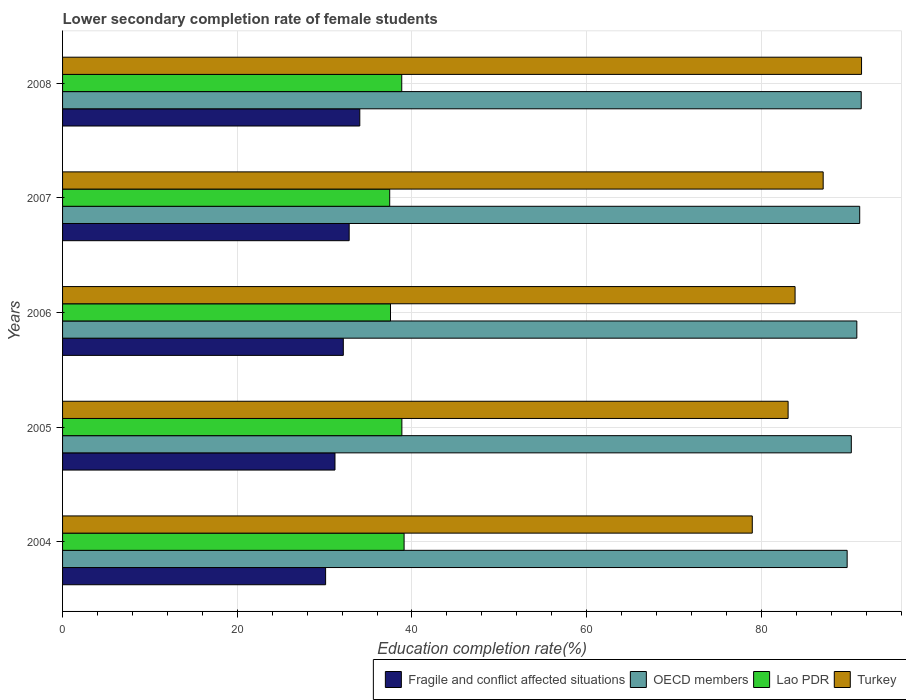How many groups of bars are there?
Give a very brief answer. 5. Are the number of bars per tick equal to the number of legend labels?
Your response must be concise. Yes. Are the number of bars on each tick of the Y-axis equal?
Provide a short and direct response. Yes. What is the label of the 4th group of bars from the top?
Provide a succinct answer. 2005. What is the lower secondary completion rate of female students in OECD members in 2004?
Your response must be concise. 89.82. Across all years, what is the maximum lower secondary completion rate of female students in Lao PDR?
Make the answer very short. 39.1. Across all years, what is the minimum lower secondary completion rate of female students in OECD members?
Offer a very short reply. 89.82. What is the total lower secondary completion rate of female students in Lao PDR in the graph?
Give a very brief answer. 191.76. What is the difference between the lower secondary completion rate of female students in Lao PDR in 2004 and that in 2005?
Your answer should be compact. 0.25. What is the difference between the lower secondary completion rate of female students in OECD members in 2006 and the lower secondary completion rate of female students in Fragile and conflict affected situations in 2005?
Provide a succinct answer. 59.74. What is the average lower secondary completion rate of female students in Lao PDR per year?
Give a very brief answer. 38.35. In the year 2006, what is the difference between the lower secondary completion rate of female students in Turkey and lower secondary completion rate of female students in Lao PDR?
Give a very brief answer. 46.31. In how many years, is the lower secondary completion rate of female students in OECD members greater than 4 %?
Your answer should be very brief. 5. What is the ratio of the lower secondary completion rate of female students in OECD members in 2004 to that in 2007?
Your response must be concise. 0.98. Is the lower secondary completion rate of female students in Lao PDR in 2004 less than that in 2006?
Your answer should be compact. No. What is the difference between the highest and the second highest lower secondary completion rate of female students in OECD members?
Offer a terse response. 0.17. What is the difference between the highest and the lowest lower secondary completion rate of female students in Fragile and conflict affected situations?
Provide a succinct answer. 3.91. What does the 4th bar from the top in 2008 represents?
Provide a short and direct response. Fragile and conflict affected situations. What does the 1st bar from the bottom in 2005 represents?
Your answer should be compact. Fragile and conflict affected situations. How many years are there in the graph?
Your response must be concise. 5. What is the difference between two consecutive major ticks on the X-axis?
Provide a succinct answer. 20. Does the graph contain grids?
Offer a terse response. Yes. Where does the legend appear in the graph?
Give a very brief answer. Bottom right. How many legend labels are there?
Make the answer very short. 4. How are the legend labels stacked?
Give a very brief answer. Horizontal. What is the title of the graph?
Give a very brief answer. Lower secondary completion rate of female students. Does "Australia" appear as one of the legend labels in the graph?
Provide a succinct answer. No. What is the label or title of the X-axis?
Your response must be concise. Education completion rate(%). What is the Education completion rate(%) of Fragile and conflict affected situations in 2004?
Offer a terse response. 30.11. What is the Education completion rate(%) in OECD members in 2004?
Your answer should be compact. 89.82. What is the Education completion rate(%) of Lao PDR in 2004?
Your answer should be compact. 39.1. What is the Education completion rate(%) in Turkey in 2004?
Your answer should be compact. 78.96. What is the Education completion rate(%) of Fragile and conflict affected situations in 2005?
Keep it short and to the point. 31.19. What is the Education completion rate(%) of OECD members in 2005?
Your answer should be compact. 90.29. What is the Education completion rate(%) of Lao PDR in 2005?
Provide a succinct answer. 38.84. What is the Education completion rate(%) in Turkey in 2005?
Provide a short and direct response. 83.06. What is the Education completion rate(%) in Fragile and conflict affected situations in 2006?
Offer a very short reply. 32.14. What is the Education completion rate(%) in OECD members in 2006?
Keep it short and to the point. 90.93. What is the Education completion rate(%) of Lao PDR in 2006?
Provide a succinct answer. 37.54. What is the Education completion rate(%) in Turkey in 2006?
Provide a succinct answer. 83.86. What is the Education completion rate(%) of Fragile and conflict affected situations in 2007?
Give a very brief answer. 32.81. What is the Education completion rate(%) in OECD members in 2007?
Give a very brief answer. 91.25. What is the Education completion rate(%) in Lao PDR in 2007?
Your response must be concise. 37.45. What is the Education completion rate(%) of Turkey in 2007?
Provide a succinct answer. 87.07. What is the Education completion rate(%) of Fragile and conflict affected situations in 2008?
Give a very brief answer. 34.03. What is the Education completion rate(%) in OECD members in 2008?
Keep it short and to the point. 91.43. What is the Education completion rate(%) of Lao PDR in 2008?
Give a very brief answer. 38.83. What is the Education completion rate(%) in Turkey in 2008?
Ensure brevity in your answer.  91.46. Across all years, what is the maximum Education completion rate(%) of Fragile and conflict affected situations?
Provide a short and direct response. 34.03. Across all years, what is the maximum Education completion rate(%) in OECD members?
Provide a short and direct response. 91.43. Across all years, what is the maximum Education completion rate(%) in Lao PDR?
Keep it short and to the point. 39.1. Across all years, what is the maximum Education completion rate(%) of Turkey?
Provide a short and direct response. 91.46. Across all years, what is the minimum Education completion rate(%) in Fragile and conflict affected situations?
Your answer should be very brief. 30.11. Across all years, what is the minimum Education completion rate(%) of OECD members?
Give a very brief answer. 89.82. Across all years, what is the minimum Education completion rate(%) in Lao PDR?
Provide a short and direct response. 37.45. Across all years, what is the minimum Education completion rate(%) of Turkey?
Your response must be concise. 78.96. What is the total Education completion rate(%) of Fragile and conflict affected situations in the graph?
Ensure brevity in your answer.  160.27. What is the total Education completion rate(%) in OECD members in the graph?
Offer a terse response. 453.72. What is the total Education completion rate(%) in Lao PDR in the graph?
Offer a terse response. 191.76. What is the total Education completion rate(%) of Turkey in the graph?
Your response must be concise. 424.41. What is the difference between the Education completion rate(%) of Fragile and conflict affected situations in 2004 and that in 2005?
Ensure brevity in your answer.  -1.07. What is the difference between the Education completion rate(%) in OECD members in 2004 and that in 2005?
Give a very brief answer. -0.48. What is the difference between the Education completion rate(%) in Lao PDR in 2004 and that in 2005?
Your response must be concise. 0.25. What is the difference between the Education completion rate(%) in Turkey in 2004 and that in 2005?
Provide a succinct answer. -4.1. What is the difference between the Education completion rate(%) in Fragile and conflict affected situations in 2004 and that in 2006?
Give a very brief answer. -2.03. What is the difference between the Education completion rate(%) of OECD members in 2004 and that in 2006?
Keep it short and to the point. -1.11. What is the difference between the Education completion rate(%) of Lao PDR in 2004 and that in 2006?
Offer a very short reply. 1.56. What is the difference between the Education completion rate(%) in Turkey in 2004 and that in 2006?
Make the answer very short. -4.9. What is the difference between the Education completion rate(%) of Fragile and conflict affected situations in 2004 and that in 2007?
Your answer should be very brief. -2.7. What is the difference between the Education completion rate(%) of OECD members in 2004 and that in 2007?
Your answer should be compact. -1.44. What is the difference between the Education completion rate(%) of Lao PDR in 2004 and that in 2007?
Make the answer very short. 1.65. What is the difference between the Education completion rate(%) in Turkey in 2004 and that in 2007?
Offer a terse response. -8.12. What is the difference between the Education completion rate(%) in Fragile and conflict affected situations in 2004 and that in 2008?
Make the answer very short. -3.91. What is the difference between the Education completion rate(%) of OECD members in 2004 and that in 2008?
Ensure brevity in your answer.  -1.61. What is the difference between the Education completion rate(%) of Lao PDR in 2004 and that in 2008?
Provide a short and direct response. 0.27. What is the difference between the Education completion rate(%) in Turkey in 2004 and that in 2008?
Keep it short and to the point. -12.51. What is the difference between the Education completion rate(%) in Fragile and conflict affected situations in 2005 and that in 2006?
Make the answer very short. -0.95. What is the difference between the Education completion rate(%) in OECD members in 2005 and that in 2006?
Make the answer very short. -0.63. What is the difference between the Education completion rate(%) in Lao PDR in 2005 and that in 2006?
Your answer should be compact. 1.3. What is the difference between the Education completion rate(%) of Turkey in 2005 and that in 2006?
Your answer should be compact. -0.8. What is the difference between the Education completion rate(%) in Fragile and conflict affected situations in 2005 and that in 2007?
Make the answer very short. -1.62. What is the difference between the Education completion rate(%) in OECD members in 2005 and that in 2007?
Give a very brief answer. -0.96. What is the difference between the Education completion rate(%) in Lao PDR in 2005 and that in 2007?
Ensure brevity in your answer.  1.39. What is the difference between the Education completion rate(%) of Turkey in 2005 and that in 2007?
Your response must be concise. -4.01. What is the difference between the Education completion rate(%) in Fragile and conflict affected situations in 2005 and that in 2008?
Make the answer very short. -2.84. What is the difference between the Education completion rate(%) of OECD members in 2005 and that in 2008?
Make the answer very short. -1.13. What is the difference between the Education completion rate(%) in Lao PDR in 2005 and that in 2008?
Keep it short and to the point. 0.02. What is the difference between the Education completion rate(%) of Turkey in 2005 and that in 2008?
Your answer should be compact. -8.41. What is the difference between the Education completion rate(%) in Fragile and conflict affected situations in 2006 and that in 2007?
Offer a very short reply. -0.67. What is the difference between the Education completion rate(%) in OECD members in 2006 and that in 2007?
Your response must be concise. -0.33. What is the difference between the Education completion rate(%) in Lao PDR in 2006 and that in 2007?
Provide a short and direct response. 0.09. What is the difference between the Education completion rate(%) in Turkey in 2006 and that in 2007?
Offer a very short reply. -3.22. What is the difference between the Education completion rate(%) of Fragile and conflict affected situations in 2006 and that in 2008?
Give a very brief answer. -1.89. What is the difference between the Education completion rate(%) in OECD members in 2006 and that in 2008?
Provide a short and direct response. -0.5. What is the difference between the Education completion rate(%) of Lao PDR in 2006 and that in 2008?
Offer a terse response. -1.29. What is the difference between the Education completion rate(%) in Turkey in 2006 and that in 2008?
Your response must be concise. -7.61. What is the difference between the Education completion rate(%) of Fragile and conflict affected situations in 2007 and that in 2008?
Offer a terse response. -1.22. What is the difference between the Education completion rate(%) in OECD members in 2007 and that in 2008?
Your answer should be compact. -0.17. What is the difference between the Education completion rate(%) of Lao PDR in 2007 and that in 2008?
Offer a terse response. -1.38. What is the difference between the Education completion rate(%) in Turkey in 2007 and that in 2008?
Provide a succinct answer. -4.39. What is the difference between the Education completion rate(%) of Fragile and conflict affected situations in 2004 and the Education completion rate(%) of OECD members in 2005?
Provide a short and direct response. -60.18. What is the difference between the Education completion rate(%) of Fragile and conflict affected situations in 2004 and the Education completion rate(%) of Lao PDR in 2005?
Ensure brevity in your answer.  -8.73. What is the difference between the Education completion rate(%) of Fragile and conflict affected situations in 2004 and the Education completion rate(%) of Turkey in 2005?
Offer a very short reply. -52.95. What is the difference between the Education completion rate(%) in OECD members in 2004 and the Education completion rate(%) in Lao PDR in 2005?
Make the answer very short. 50.97. What is the difference between the Education completion rate(%) in OECD members in 2004 and the Education completion rate(%) in Turkey in 2005?
Your response must be concise. 6.76. What is the difference between the Education completion rate(%) of Lao PDR in 2004 and the Education completion rate(%) of Turkey in 2005?
Keep it short and to the point. -43.96. What is the difference between the Education completion rate(%) of Fragile and conflict affected situations in 2004 and the Education completion rate(%) of OECD members in 2006?
Provide a short and direct response. -60.81. What is the difference between the Education completion rate(%) in Fragile and conflict affected situations in 2004 and the Education completion rate(%) in Lao PDR in 2006?
Ensure brevity in your answer.  -7.43. What is the difference between the Education completion rate(%) in Fragile and conflict affected situations in 2004 and the Education completion rate(%) in Turkey in 2006?
Offer a terse response. -53.74. What is the difference between the Education completion rate(%) in OECD members in 2004 and the Education completion rate(%) in Lao PDR in 2006?
Provide a short and direct response. 52.28. What is the difference between the Education completion rate(%) in OECD members in 2004 and the Education completion rate(%) in Turkey in 2006?
Your answer should be compact. 5.96. What is the difference between the Education completion rate(%) of Lao PDR in 2004 and the Education completion rate(%) of Turkey in 2006?
Keep it short and to the point. -44.76. What is the difference between the Education completion rate(%) of Fragile and conflict affected situations in 2004 and the Education completion rate(%) of OECD members in 2007?
Give a very brief answer. -61.14. What is the difference between the Education completion rate(%) of Fragile and conflict affected situations in 2004 and the Education completion rate(%) of Lao PDR in 2007?
Give a very brief answer. -7.34. What is the difference between the Education completion rate(%) of Fragile and conflict affected situations in 2004 and the Education completion rate(%) of Turkey in 2007?
Ensure brevity in your answer.  -56.96. What is the difference between the Education completion rate(%) in OECD members in 2004 and the Education completion rate(%) in Lao PDR in 2007?
Offer a very short reply. 52.37. What is the difference between the Education completion rate(%) in OECD members in 2004 and the Education completion rate(%) in Turkey in 2007?
Keep it short and to the point. 2.75. What is the difference between the Education completion rate(%) in Lao PDR in 2004 and the Education completion rate(%) in Turkey in 2007?
Make the answer very short. -47.98. What is the difference between the Education completion rate(%) in Fragile and conflict affected situations in 2004 and the Education completion rate(%) in OECD members in 2008?
Your answer should be compact. -61.31. What is the difference between the Education completion rate(%) of Fragile and conflict affected situations in 2004 and the Education completion rate(%) of Lao PDR in 2008?
Your response must be concise. -8.71. What is the difference between the Education completion rate(%) of Fragile and conflict affected situations in 2004 and the Education completion rate(%) of Turkey in 2008?
Your answer should be compact. -61.35. What is the difference between the Education completion rate(%) of OECD members in 2004 and the Education completion rate(%) of Lao PDR in 2008?
Give a very brief answer. 50.99. What is the difference between the Education completion rate(%) of OECD members in 2004 and the Education completion rate(%) of Turkey in 2008?
Keep it short and to the point. -1.65. What is the difference between the Education completion rate(%) of Lao PDR in 2004 and the Education completion rate(%) of Turkey in 2008?
Offer a very short reply. -52.37. What is the difference between the Education completion rate(%) of Fragile and conflict affected situations in 2005 and the Education completion rate(%) of OECD members in 2006?
Provide a short and direct response. -59.74. What is the difference between the Education completion rate(%) in Fragile and conflict affected situations in 2005 and the Education completion rate(%) in Lao PDR in 2006?
Keep it short and to the point. -6.36. What is the difference between the Education completion rate(%) in Fragile and conflict affected situations in 2005 and the Education completion rate(%) in Turkey in 2006?
Offer a terse response. -52.67. What is the difference between the Education completion rate(%) in OECD members in 2005 and the Education completion rate(%) in Lao PDR in 2006?
Give a very brief answer. 52.75. What is the difference between the Education completion rate(%) in OECD members in 2005 and the Education completion rate(%) in Turkey in 2006?
Offer a very short reply. 6.44. What is the difference between the Education completion rate(%) in Lao PDR in 2005 and the Education completion rate(%) in Turkey in 2006?
Provide a succinct answer. -45.01. What is the difference between the Education completion rate(%) in Fragile and conflict affected situations in 2005 and the Education completion rate(%) in OECD members in 2007?
Your answer should be very brief. -60.07. What is the difference between the Education completion rate(%) of Fragile and conflict affected situations in 2005 and the Education completion rate(%) of Lao PDR in 2007?
Your answer should be compact. -6.26. What is the difference between the Education completion rate(%) of Fragile and conflict affected situations in 2005 and the Education completion rate(%) of Turkey in 2007?
Give a very brief answer. -55.89. What is the difference between the Education completion rate(%) of OECD members in 2005 and the Education completion rate(%) of Lao PDR in 2007?
Offer a terse response. 52.84. What is the difference between the Education completion rate(%) in OECD members in 2005 and the Education completion rate(%) in Turkey in 2007?
Keep it short and to the point. 3.22. What is the difference between the Education completion rate(%) of Lao PDR in 2005 and the Education completion rate(%) of Turkey in 2007?
Your answer should be compact. -48.23. What is the difference between the Education completion rate(%) of Fragile and conflict affected situations in 2005 and the Education completion rate(%) of OECD members in 2008?
Your response must be concise. -60.24. What is the difference between the Education completion rate(%) of Fragile and conflict affected situations in 2005 and the Education completion rate(%) of Lao PDR in 2008?
Your answer should be very brief. -7.64. What is the difference between the Education completion rate(%) of Fragile and conflict affected situations in 2005 and the Education completion rate(%) of Turkey in 2008?
Make the answer very short. -60.28. What is the difference between the Education completion rate(%) in OECD members in 2005 and the Education completion rate(%) in Lao PDR in 2008?
Keep it short and to the point. 51.47. What is the difference between the Education completion rate(%) of OECD members in 2005 and the Education completion rate(%) of Turkey in 2008?
Offer a very short reply. -1.17. What is the difference between the Education completion rate(%) in Lao PDR in 2005 and the Education completion rate(%) in Turkey in 2008?
Your response must be concise. -52.62. What is the difference between the Education completion rate(%) in Fragile and conflict affected situations in 2006 and the Education completion rate(%) in OECD members in 2007?
Your response must be concise. -59.12. What is the difference between the Education completion rate(%) in Fragile and conflict affected situations in 2006 and the Education completion rate(%) in Lao PDR in 2007?
Provide a short and direct response. -5.31. What is the difference between the Education completion rate(%) in Fragile and conflict affected situations in 2006 and the Education completion rate(%) in Turkey in 2007?
Offer a terse response. -54.93. What is the difference between the Education completion rate(%) of OECD members in 2006 and the Education completion rate(%) of Lao PDR in 2007?
Your answer should be very brief. 53.48. What is the difference between the Education completion rate(%) in OECD members in 2006 and the Education completion rate(%) in Turkey in 2007?
Your answer should be compact. 3.85. What is the difference between the Education completion rate(%) in Lao PDR in 2006 and the Education completion rate(%) in Turkey in 2007?
Offer a very short reply. -49.53. What is the difference between the Education completion rate(%) in Fragile and conflict affected situations in 2006 and the Education completion rate(%) in OECD members in 2008?
Your answer should be compact. -59.29. What is the difference between the Education completion rate(%) of Fragile and conflict affected situations in 2006 and the Education completion rate(%) of Lao PDR in 2008?
Your answer should be very brief. -6.69. What is the difference between the Education completion rate(%) of Fragile and conflict affected situations in 2006 and the Education completion rate(%) of Turkey in 2008?
Offer a very short reply. -59.33. What is the difference between the Education completion rate(%) in OECD members in 2006 and the Education completion rate(%) in Lao PDR in 2008?
Your answer should be compact. 52.1. What is the difference between the Education completion rate(%) in OECD members in 2006 and the Education completion rate(%) in Turkey in 2008?
Ensure brevity in your answer.  -0.54. What is the difference between the Education completion rate(%) of Lao PDR in 2006 and the Education completion rate(%) of Turkey in 2008?
Your response must be concise. -53.92. What is the difference between the Education completion rate(%) of Fragile and conflict affected situations in 2007 and the Education completion rate(%) of OECD members in 2008?
Keep it short and to the point. -58.62. What is the difference between the Education completion rate(%) in Fragile and conflict affected situations in 2007 and the Education completion rate(%) in Lao PDR in 2008?
Ensure brevity in your answer.  -6.02. What is the difference between the Education completion rate(%) of Fragile and conflict affected situations in 2007 and the Education completion rate(%) of Turkey in 2008?
Your response must be concise. -58.65. What is the difference between the Education completion rate(%) of OECD members in 2007 and the Education completion rate(%) of Lao PDR in 2008?
Ensure brevity in your answer.  52.43. What is the difference between the Education completion rate(%) of OECD members in 2007 and the Education completion rate(%) of Turkey in 2008?
Your answer should be compact. -0.21. What is the difference between the Education completion rate(%) of Lao PDR in 2007 and the Education completion rate(%) of Turkey in 2008?
Your answer should be compact. -54.01. What is the average Education completion rate(%) of Fragile and conflict affected situations per year?
Keep it short and to the point. 32.05. What is the average Education completion rate(%) in OECD members per year?
Make the answer very short. 90.74. What is the average Education completion rate(%) in Lao PDR per year?
Provide a succinct answer. 38.35. What is the average Education completion rate(%) in Turkey per year?
Provide a succinct answer. 84.88. In the year 2004, what is the difference between the Education completion rate(%) of Fragile and conflict affected situations and Education completion rate(%) of OECD members?
Provide a short and direct response. -59.7. In the year 2004, what is the difference between the Education completion rate(%) in Fragile and conflict affected situations and Education completion rate(%) in Lao PDR?
Your response must be concise. -8.98. In the year 2004, what is the difference between the Education completion rate(%) of Fragile and conflict affected situations and Education completion rate(%) of Turkey?
Your response must be concise. -48.84. In the year 2004, what is the difference between the Education completion rate(%) in OECD members and Education completion rate(%) in Lao PDR?
Your response must be concise. 50.72. In the year 2004, what is the difference between the Education completion rate(%) in OECD members and Education completion rate(%) in Turkey?
Provide a short and direct response. 10.86. In the year 2004, what is the difference between the Education completion rate(%) of Lao PDR and Education completion rate(%) of Turkey?
Your answer should be compact. -39.86. In the year 2005, what is the difference between the Education completion rate(%) of Fragile and conflict affected situations and Education completion rate(%) of OECD members?
Keep it short and to the point. -59.11. In the year 2005, what is the difference between the Education completion rate(%) of Fragile and conflict affected situations and Education completion rate(%) of Lao PDR?
Your answer should be very brief. -7.66. In the year 2005, what is the difference between the Education completion rate(%) in Fragile and conflict affected situations and Education completion rate(%) in Turkey?
Your answer should be compact. -51.87. In the year 2005, what is the difference between the Education completion rate(%) of OECD members and Education completion rate(%) of Lao PDR?
Provide a succinct answer. 51.45. In the year 2005, what is the difference between the Education completion rate(%) in OECD members and Education completion rate(%) in Turkey?
Your answer should be compact. 7.24. In the year 2005, what is the difference between the Education completion rate(%) in Lao PDR and Education completion rate(%) in Turkey?
Give a very brief answer. -44.21. In the year 2006, what is the difference between the Education completion rate(%) in Fragile and conflict affected situations and Education completion rate(%) in OECD members?
Your answer should be compact. -58.79. In the year 2006, what is the difference between the Education completion rate(%) of Fragile and conflict affected situations and Education completion rate(%) of Lao PDR?
Make the answer very short. -5.4. In the year 2006, what is the difference between the Education completion rate(%) of Fragile and conflict affected situations and Education completion rate(%) of Turkey?
Your answer should be very brief. -51.72. In the year 2006, what is the difference between the Education completion rate(%) of OECD members and Education completion rate(%) of Lao PDR?
Your answer should be compact. 53.38. In the year 2006, what is the difference between the Education completion rate(%) of OECD members and Education completion rate(%) of Turkey?
Give a very brief answer. 7.07. In the year 2006, what is the difference between the Education completion rate(%) in Lao PDR and Education completion rate(%) in Turkey?
Provide a short and direct response. -46.31. In the year 2007, what is the difference between the Education completion rate(%) in Fragile and conflict affected situations and Education completion rate(%) in OECD members?
Make the answer very short. -58.44. In the year 2007, what is the difference between the Education completion rate(%) in Fragile and conflict affected situations and Education completion rate(%) in Lao PDR?
Ensure brevity in your answer.  -4.64. In the year 2007, what is the difference between the Education completion rate(%) of Fragile and conflict affected situations and Education completion rate(%) of Turkey?
Provide a succinct answer. -54.26. In the year 2007, what is the difference between the Education completion rate(%) of OECD members and Education completion rate(%) of Lao PDR?
Ensure brevity in your answer.  53.8. In the year 2007, what is the difference between the Education completion rate(%) of OECD members and Education completion rate(%) of Turkey?
Your response must be concise. 4.18. In the year 2007, what is the difference between the Education completion rate(%) in Lao PDR and Education completion rate(%) in Turkey?
Offer a terse response. -49.62. In the year 2008, what is the difference between the Education completion rate(%) of Fragile and conflict affected situations and Education completion rate(%) of OECD members?
Ensure brevity in your answer.  -57.4. In the year 2008, what is the difference between the Education completion rate(%) in Fragile and conflict affected situations and Education completion rate(%) in Lao PDR?
Make the answer very short. -4.8. In the year 2008, what is the difference between the Education completion rate(%) of Fragile and conflict affected situations and Education completion rate(%) of Turkey?
Offer a terse response. -57.44. In the year 2008, what is the difference between the Education completion rate(%) in OECD members and Education completion rate(%) in Lao PDR?
Your response must be concise. 52.6. In the year 2008, what is the difference between the Education completion rate(%) of OECD members and Education completion rate(%) of Turkey?
Keep it short and to the point. -0.04. In the year 2008, what is the difference between the Education completion rate(%) of Lao PDR and Education completion rate(%) of Turkey?
Make the answer very short. -52.64. What is the ratio of the Education completion rate(%) in Fragile and conflict affected situations in 2004 to that in 2005?
Your response must be concise. 0.97. What is the ratio of the Education completion rate(%) in OECD members in 2004 to that in 2005?
Give a very brief answer. 0.99. What is the ratio of the Education completion rate(%) of Lao PDR in 2004 to that in 2005?
Ensure brevity in your answer.  1.01. What is the ratio of the Education completion rate(%) in Turkey in 2004 to that in 2005?
Offer a very short reply. 0.95. What is the ratio of the Education completion rate(%) of Fragile and conflict affected situations in 2004 to that in 2006?
Keep it short and to the point. 0.94. What is the ratio of the Education completion rate(%) of Lao PDR in 2004 to that in 2006?
Ensure brevity in your answer.  1.04. What is the ratio of the Education completion rate(%) in Turkey in 2004 to that in 2006?
Keep it short and to the point. 0.94. What is the ratio of the Education completion rate(%) of Fragile and conflict affected situations in 2004 to that in 2007?
Give a very brief answer. 0.92. What is the ratio of the Education completion rate(%) in OECD members in 2004 to that in 2007?
Your answer should be very brief. 0.98. What is the ratio of the Education completion rate(%) of Lao PDR in 2004 to that in 2007?
Keep it short and to the point. 1.04. What is the ratio of the Education completion rate(%) in Turkey in 2004 to that in 2007?
Provide a short and direct response. 0.91. What is the ratio of the Education completion rate(%) of Fragile and conflict affected situations in 2004 to that in 2008?
Your answer should be very brief. 0.89. What is the ratio of the Education completion rate(%) of OECD members in 2004 to that in 2008?
Offer a very short reply. 0.98. What is the ratio of the Education completion rate(%) of Lao PDR in 2004 to that in 2008?
Keep it short and to the point. 1.01. What is the ratio of the Education completion rate(%) of Turkey in 2004 to that in 2008?
Keep it short and to the point. 0.86. What is the ratio of the Education completion rate(%) in Fragile and conflict affected situations in 2005 to that in 2006?
Give a very brief answer. 0.97. What is the ratio of the Education completion rate(%) of Lao PDR in 2005 to that in 2006?
Ensure brevity in your answer.  1.03. What is the ratio of the Education completion rate(%) in Turkey in 2005 to that in 2006?
Ensure brevity in your answer.  0.99. What is the ratio of the Education completion rate(%) of Fragile and conflict affected situations in 2005 to that in 2007?
Provide a succinct answer. 0.95. What is the ratio of the Education completion rate(%) in Lao PDR in 2005 to that in 2007?
Ensure brevity in your answer.  1.04. What is the ratio of the Education completion rate(%) of Turkey in 2005 to that in 2007?
Your answer should be very brief. 0.95. What is the ratio of the Education completion rate(%) in Fragile and conflict affected situations in 2005 to that in 2008?
Your answer should be very brief. 0.92. What is the ratio of the Education completion rate(%) in OECD members in 2005 to that in 2008?
Give a very brief answer. 0.99. What is the ratio of the Education completion rate(%) in Lao PDR in 2005 to that in 2008?
Provide a short and direct response. 1. What is the ratio of the Education completion rate(%) of Turkey in 2005 to that in 2008?
Your answer should be very brief. 0.91. What is the ratio of the Education completion rate(%) in Fragile and conflict affected situations in 2006 to that in 2007?
Your answer should be very brief. 0.98. What is the ratio of the Education completion rate(%) of OECD members in 2006 to that in 2007?
Provide a short and direct response. 1. What is the ratio of the Education completion rate(%) of Lao PDR in 2006 to that in 2007?
Give a very brief answer. 1. What is the ratio of the Education completion rate(%) in Turkey in 2006 to that in 2007?
Provide a short and direct response. 0.96. What is the ratio of the Education completion rate(%) of Fragile and conflict affected situations in 2006 to that in 2008?
Keep it short and to the point. 0.94. What is the ratio of the Education completion rate(%) of Lao PDR in 2006 to that in 2008?
Your response must be concise. 0.97. What is the ratio of the Education completion rate(%) in Turkey in 2006 to that in 2008?
Provide a short and direct response. 0.92. What is the ratio of the Education completion rate(%) in Fragile and conflict affected situations in 2007 to that in 2008?
Ensure brevity in your answer.  0.96. What is the ratio of the Education completion rate(%) in OECD members in 2007 to that in 2008?
Ensure brevity in your answer.  1. What is the ratio of the Education completion rate(%) in Lao PDR in 2007 to that in 2008?
Provide a short and direct response. 0.96. What is the ratio of the Education completion rate(%) of Turkey in 2007 to that in 2008?
Offer a terse response. 0.95. What is the difference between the highest and the second highest Education completion rate(%) in Fragile and conflict affected situations?
Offer a very short reply. 1.22. What is the difference between the highest and the second highest Education completion rate(%) in OECD members?
Offer a terse response. 0.17. What is the difference between the highest and the second highest Education completion rate(%) in Lao PDR?
Your answer should be very brief. 0.25. What is the difference between the highest and the second highest Education completion rate(%) of Turkey?
Your answer should be very brief. 4.39. What is the difference between the highest and the lowest Education completion rate(%) of Fragile and conflict affected situations?
Your answer should be compact. 3.91. What is the difference between the highest and the lowest Education completion rate(%) in OECD members?
Your answer should be compact. 1.61. What is the difference between the highest and the lowest Education completion rate(%) in Lao PDR?
Give a very brief answer. 1.65. What is the difference between the highest and the lowest Education completion rate(%) in Turkey?
Your answer should be compact. 12.51. 